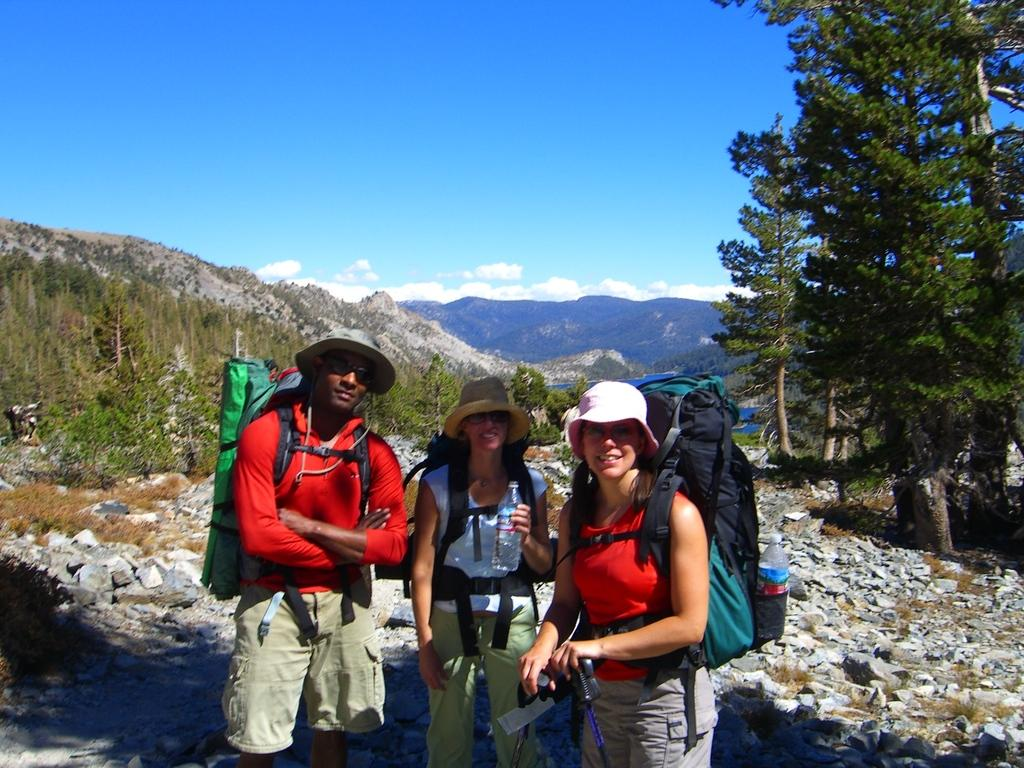How many people are in the image? There are three people in the image. What are the people doing in the image? The people are standing with their backpacks on the ground. What can be seen in the background of the image? There are mountains, clouds, the sky, and trees visible in the background of the image. Where is the throne located in the image? There is no throne present in the image. What type of soup is being served in the image? There is no soup present in the image. 